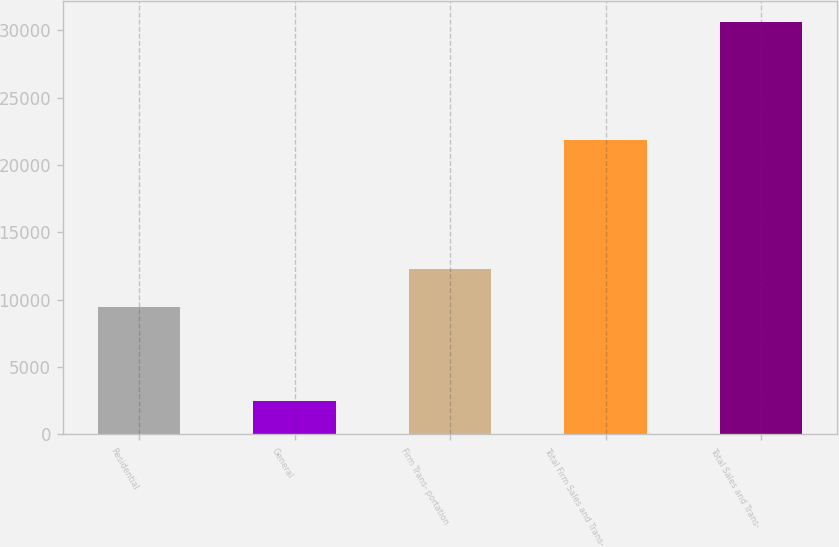Convert chart to OTSL. <chart><loc_0><loc_0><loc_500><loc_500><bar_chart><fcel>Residential<fcel>General<fcel>Firm Trans- portation<fcel>Total Firm Sales and Trans-<fcel>Total Sales and Trans-<nl><fcel>9487<fcel>2487<fcel>12301.1<fcel>21905<fcel>30628<nl></chart> 